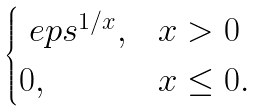Convert formula to latex. <formula><loc_0><loc_0><loc_500><loc_500>\begin{cases} \ e p s ^ { 1 / x } , & x > 0 \\ 0 , & x \leq 0 . \end{cases}</formula> 